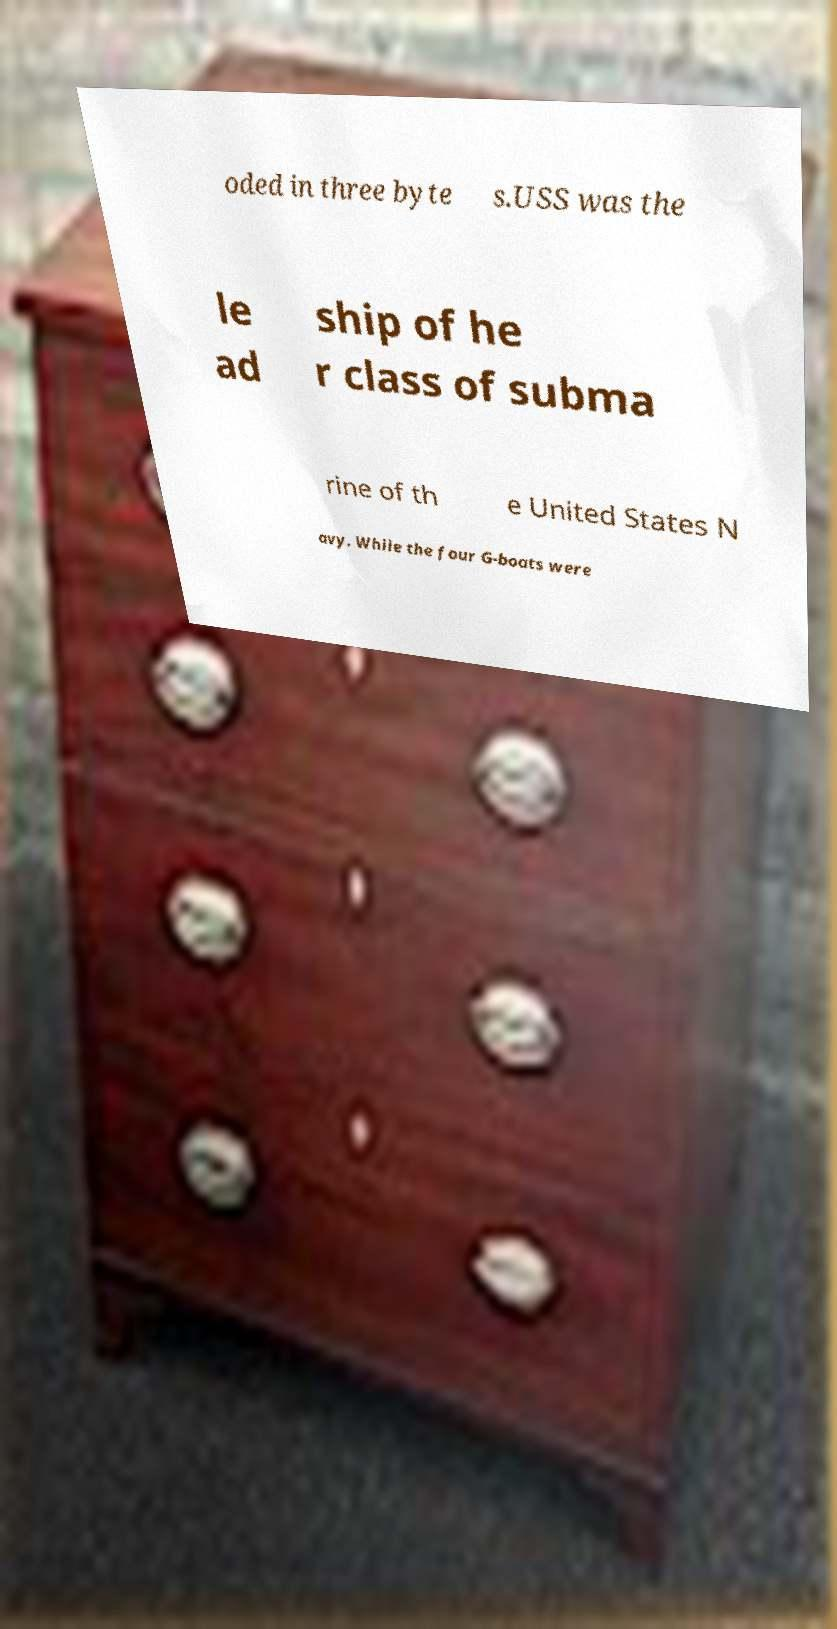Can you accurately transcribe the text from the provided image for me? oded in three byte s.USS was the le ad ship of he r class of subma rine of th e United States N avy. While the four G-boats were 